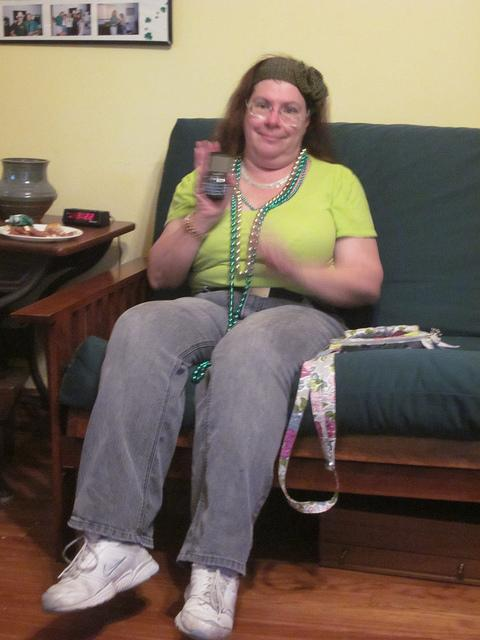What is the woman celebrating with her beads? Please explain your reasoning. mardi gras. Mardi gras features purple, green and gold beads. 